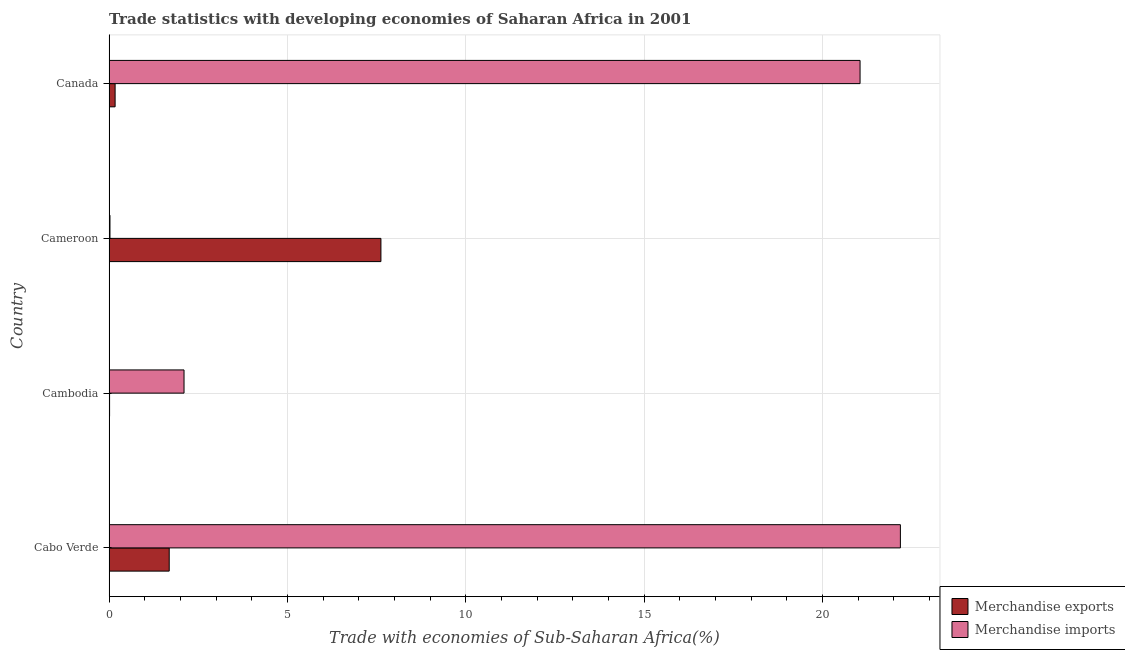How many different coloured bars are there?
Your response must be concise. 2. What is the label of the 4th group of bars from the top?
Give a very brief answer. Cabo Verde. In how many cases, is the number of bars for a given country not equal to the number of legend labels?
Offer a very short reply. 0. What is the merchandise exports in Cambodia?
Make the answer very short. 0.01. Across all countries, what is the maximum merchandise exports?
Offer a terse response. 7.62. Across all countries, what is the minimum merchandise imports?
Provide a succinct answer. 0.03. In which country was the merchandise exports maximum?
Provide a succinct answer. Cameroon. In which country was the merchandise imports minimum?
Your answer should be compact. Cameroon. What is the total merchandise imports in the graph?
Offer a very short reply. 45.36. What is the difference between the merchandise exports in Cambodia and that in Cameroon?
Keep it short and to the point. -7.61. What is the difference between the merchandise exports in Canada and the merchandise imports in Cambodia?
Offer a very short reply. -1.93. What is the average merchandise imports per country?
Provide a short and direct response. 11.34. What is the difference between the merchandise exports and merchandise imports in Cambodia?
Keep it short and to the point. -2.09. In how many countries, is the merchandise exports greater than 14 %?
Ensure brevity in your answer.  0. What is the ratio of the merchandise imports in Cabo Verde to that in Canada?
Your answer should be compact. 1.05. Is the merchandise exports in Cambodia less than that in Canada?
Your answer should be very brief. Yes. What is the difference between the highest and the second highest merchandise exports?
Your response must be concise. 5.93. What is the difference between the highest and the lowest merchandise imports?
Your answer should be compact. 22.16. Is the sum of the merchandise exports in Cabo Verde and Cameroon greater than the maximum merchandise imports across all countries?
Offer a very short reply. No. What does the 2nd bar from the top in Canada represents?
Offer a terse response. Merchandise exports. How many bars are there?
Offer a terse response. 8. What is the difference between two consecutive major ticks on the X-axis?
Provide a short and direct response. 5. Are the values on the major ticks of X-axis written in scientific E-notation?
Make the answer very short. No. Does the graph contain any zero values?
Ensure brevity in your answer.  No. Does the graph contain grids?
Offer a very short reply. Yes. Where does the legend appear in the graph?
Your answer should be compact. Bottom right. How many legend labels are there?
Provide a succinct answer. 2. What is the title of the graph?
Your response must be concise. Trade statistics with developing economies of Saharan Africa in 2001. Does "Food" appear as one of the legend labels in the graph?
Offer a very short reply. No. What is the label or title of the X-axis?
Provide a succinct answer. Trade with economies of Sub-Saharan Africa(%). What is the Trade with economies of Sub-Saharan Africa(%) of Merchandise exports in Cabo Verde?
Ensure brevity in your answer.  1.69. What is the Trade with economies of Sub-Saharan Africa(%) in Merchandise imports in Cabo Verde?
Ensure brevity in your answer.  22.18. What is the Trade with economies of Sub-Saharan Africa(%) in Merchandise exports in Cambodia?
Keep it short and to the point. 0.01. What is the Trade with economies of Sub-Saharan Africa(%) of Merchandise imports in Cambodia?
Your answer should be compact. 2.1. What is the Trade with economies of Sub-Saharan Africa(%) of Merchandise exports in Cameroon?
Offer a terse response. 7.62. What is the Trade with economies of Sub-Saharan Africa(%) in Merchandise imports in Cameroon?
Offer a very short reply. 0.03. What is the Trade with economies of Sub-Saharan Africa(%) of Merchandise exports in Canada?
Provide a succinct answer. 0.17. What is the Trade with economies of Sub-Saharan Africa(%) of Merchandise imports in Canada?
Offer a very short reply. 21.05. Across all countries, what is the maximum Trade with economies of Sub-Saharan Africa(%) in Merchandise exports?
Provide a succinct answer. 7.62. Across all countries, what is the maximum Trade with economies of Sub-Saharan Africa(%) of Merchandise imports?
Your response must be concise. 22.18. Across all countries, what is the minimum Trade with economies of Sub-Saharan Africa(%) in Merchandise exports?
Your response must be concise. 0.01. Across all countries, what is the minimum Trade with economies of Sub-Saharan Africa(%) of Merchandise imports?
Keep it short and to the point. 0.03. What is the total Trade with economies of Sub-Saharan Africa(%) in Merchandise exports in the graph?
Make the answer very short. 9.49. What is the total Trade with economies of Sub-Saharan Africa(%) in Merchandise imports in the graph?
Offer a terse response. 45.36. What is the difference between the Trade with economies of Sub-Saharan Africa(%) of Merchandise exports in Cabo Verde and that in Cambodia?
Ensure brevity in your answer.  1.67. What is the difference between the Trade with economies of Sub-Saharan Africa(%) of Merchandise imports in Cabo Verde and that in Cambodia?
Ensure brevity in your answer.  20.08. What is the difference between the Trade with economies of Sub-Saharan Africa(%) in Merchandise exports in Cabo Verde and that in Cameroon?
Your answer should be very brief. -5.93. What is the difference between the Trade with economies of Sub-Saharan Africa(%) of Merchandise imports in Cabo Verde and that in Cameroon?
Offer a terse response. 22.16. What is the difference between the Trade with economies of Sub-Saharan Africa(%) of Merchandise exports in Cabo Verde and that in Canada?
Keep it short and to the point. 1.52. What is the difference between the Trade with economies of Sub-Saharan Africa(%) of Merchandise imports in Cabo Verde and that in Canada?
Make the answer very short. 1.13. What is the difference between the Trade with economies of Sub-Saharan Africa(%) of Merchandise exports in Cambodia and that in Cameroon?
Your response must be concise. -7.61. What is the difference between the Trade with economies of Sub-Saharan Africa(%) in Merchandise imports in Cambodia and that in Cameroon?
Ensure brevity in your answer.  2.08. What is the difference between the Trade with economies of Sub-Saharan Africa(%) in Merchandise exports in Cambodia and that in Canada?
Your answer should be compact. -0.16. What is the difference between the Trade with economies of Sub-Saharan Africa(%) in Merchandise imports in Cambodia and that in Canada?
Offer a very short reply. -18.95. What is the difference between the Trade with economies of Sub-Saharan Africa(%) of Merchandise exports in Cameroon and that in Canada?
Your answer should be very brief. 7.45. What is the difference between the Trade with economies of Sub-Saharan Africa(%) in Merchandise imports in Cameroon and that in Canada?
Provide a short and direct response. -21.02. What is the difference between the Trade with economies of Sub-Saharan Africa(%) of Merchandise exports in Cabo Verde and the Trade with economies of Sub-Saharan Africa(%) of Merchandise imports in Cambodia?
Keep it short and to the point. -0.42. What is the difference between the Trade with economies of Sub-Saharan Africa(%) in Merchandise exports in Cabo Verde and the Trade with economies of Sub-Saharan Africa(%) in Merchandise imports in Cameroon?
Give a very brief answer. 1.66. What is the difference between the Trade with economies of Sub-Saharan Africa(%) of Merchandise exports in Cabo Verde and the Trade with economies of Sub-Saharan Africa(%) of Merchandise imports in Canada?
Ensure brevity in your answer.  -19.36. What is the difference between the Trade with economies of Sub-Saharan Africa(%) in Merchandise exports in Cambodia and the Trade with economies of Sub-Saharan Africa(%) in Merchandise imports in Cameroon?
Ensure brevity in your answer.  -0.01. What is the difference between the Trade with economies of Sub-Saharan Africa(%) of Merchandise exports in Cambodia and the Trade with economies of Sub-Saharan Africa(%) of Merchandise imports in Canada?
Offer a very short reply. -21.04. What is the difference between the Trade with economies of Sub-Saharan Africa(%) in Merchandise exports in Cameroon and the Trade with economies of Sub-Saharan Africa(%) in Merchandise imports in Canada?
Make the answer very short. -13.43. What is the average Trade with economies of Sub-Saharan Africa(%) of Merchandise exports per country?
Offer a terse response. 2.37. What is the average Trade with economies of Sub-Saharan Africa(%) of Merchandise imports per country?
Make the answer very short. 11.34. What is the difference between the Trade with economies of Sub-Saharan Africa(%) of Merchandise exports and Trade with economies of Sub-Saharan Africa(%) of Merchandise imports in Cabo Verde?
Provide a short and direct response. -20.49. What is the difference between the Trade with economies of Sub-Saharan Africa(%) of Merchandise exports and Trade with economies of Sub-Saharan Africa(%) of Merchandise imports in Cambodia?
Make the answer very short. -2.09. What is the difference between the Trade with economies of Sub-Saharan Africa(%) in Merchandise exports and Trade with economies of Sub-Saharan Africa(%) in Merchandise imports in Cameroon?
Provide a short and direct response. 7.59. What is the difference between the Trade with economies of Sub-Saharan Africa(%) of Merchandise exports and Trade with economies of Sub-Saharan Africa(%) of Merchandise imports in Canada?
Ensure brevity in your answer.  -20.88. What is the ratio of the Trade with economies of Sub-Saharan Africa(%) in Merchandise exports in Cabo Verde to that in Cambodia?
Your answer should be compact. 119.07. What is the ratio of the Trade with economies of Sub-Saharan Africa(%) of Merchandise imports in Cabo Verde to that in Cambodia?
Offer a very short reply. 10.56. What is the ratio of the Trade with economies of Sub-Saharan Africa(%) in Merchandise exports in Cabo Verde to that in Cameroon?
Your answer should be compact. 0.22. What is the ratio of the Trade with economies of Sub-Saharan Africa(%) of Merchandise imports in Cabo Verde to that in Cameroon?
Your answer should be very brief. 872.48. What is the ratio of the Trade with economies of Sub-Saharan Africa(%) in Merchandise exports in Cabo Verde to that in Canada?
Offer a very short reply. 9.95. What is the ratio of the Trade with economies of Sub-Saharan Africa(%) in Merchandise imports in Cabo Verde to that in Canada?
Your answer should be compact. 1.05. What is the ratio of the Trade with economies of Sub-Saharan Africa(%) of Merchandise exports in Cambodia to that in Cameroon?
Make the answer very short. 0. What is the ratio of the Trade with economies of Sub-Saharan Africa(%) of Merchandise imports in Cambodia to that in Cameroon?
Ensure brevity in your answer.  82.65. What is the ratio of the Trade with economies of Sub-Saharan Africa(%) in Merchandise exports in Cambodia to that in Canada?
Your answer should be compact. 0.08. What is the ratio of the Trade with economies of Sub-Saharan Africa(%) of Merchandise imports in Cambodia to that in Canada?
Ensure brevity in your answer.  0.1. What is the ratio of the Trade with economies of Sub-Saharan Africa(%) in Merchandise exports in Cameroon to that in Canada?
Provide a succinct answer. 44.96. What is the ratio of the Trade with economies of Sub-Saharan Africa(%) in Merchandise imports in Cameroon to that in Canada?
Your answer should be very brief. 0. What is the difference between the highest and the second highest Trade with economies of Sub-Saharan Africa(%) in Merchandise exports?
Provide a succinct answer. 5.93. What is the difference between the highest and the second highest Trade with economies of Sub-Saharan Africa(%) of Merchandise imports?
Offer a terse response. 1.13. What is the difference between the highest and the lowest Trade with economies of Sub-Saharan Africa(%) of Merchandise exports?
Offer a terse response. 7.61. What is the difference between the highest and the lowest Trade with economies of Sub-Saharan Africa(%) in Merchandise imports?
Make the answer very short. 22.16. 